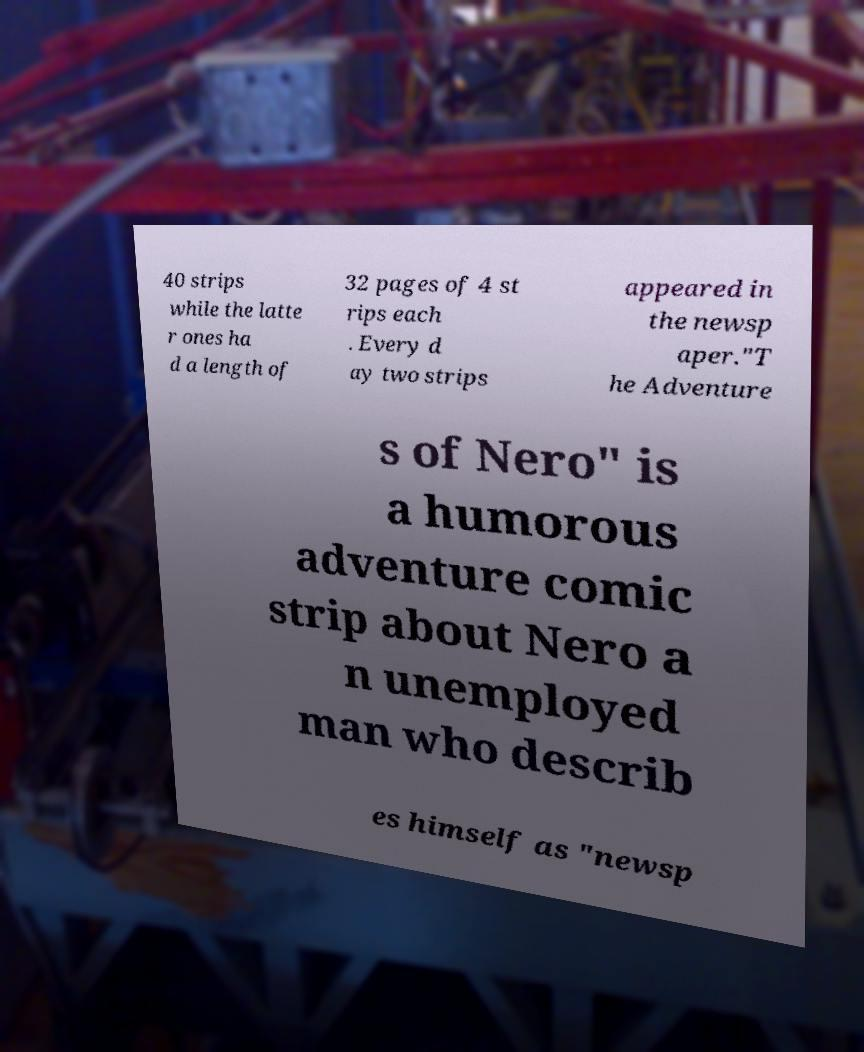Could you extract and type out the text from this image? 40 strips while the latte r ones ha d a length of 32 pages of 4 st rips each . Every d ay two strips appeared in the newsp aper."T he Adventure s of Nero" is a humorous adventure comic strip about Nero a n unemployed man who describ es himself as "newsp 